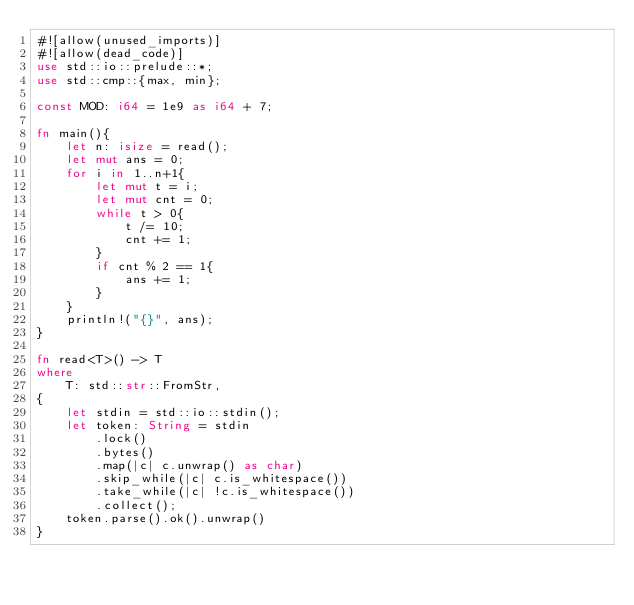<code> <loc_0><loc_0><loc_500><loc_500><_Rust_>#![allow(unused_imports)]
#![allow(dead_code)]
use std::io::prelude::*;
use std::cmp::{max, min};

const MOD: i64 = 1e9 as i64 + 7; 

fn main(){
    let n: isize = read();
    let mut ans = 0;
    for i in 1..n+1{
        let mut t = i;
        let mut cnt = 0;
        while t > 0{
            t /= 10;
            cnt += 1;
        }
        if cnt % 2 == 1{
            ans += 1;
        }
    }
    println!("{}", ans);
}

fn read<T>() -> T
where
    T: std::str::FromStr,
{
    let stdin = std::io::stdin();
    let token: String = stdin
        .lock()
        .bytes()
        .map(|c| c.unwrap() as char)
        .skip_while(|c| c.is_whitespace())
        .take_while(|c| !c.is_whitespace())
        .collect();
    token.parse().ok().unwrap()
}
</code> 